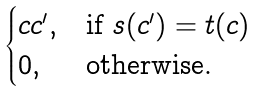Convert formula to latex. <formula><loc_0><loc_0><loc_500><loc_500>\begin{cases} c c ^ { \prime } , & \text {if } s ( c ^ { \prime } ) = t ( c ) \\ 0 , & \text {otherwise.} \end{cases}</formula> 